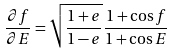<formula> <loc_0><loc_0><loc_500><loc_500>\frac { \partial f } { \partial E } = \sqrt { \frac { 1 + e } { 1 - e } } \frac { 1 + \cos f } { 1 + \cos E }</formula> 